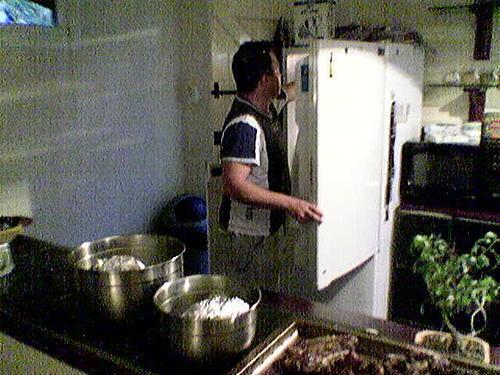How many men opening the fridge?
Give a very brief answer. 1. 